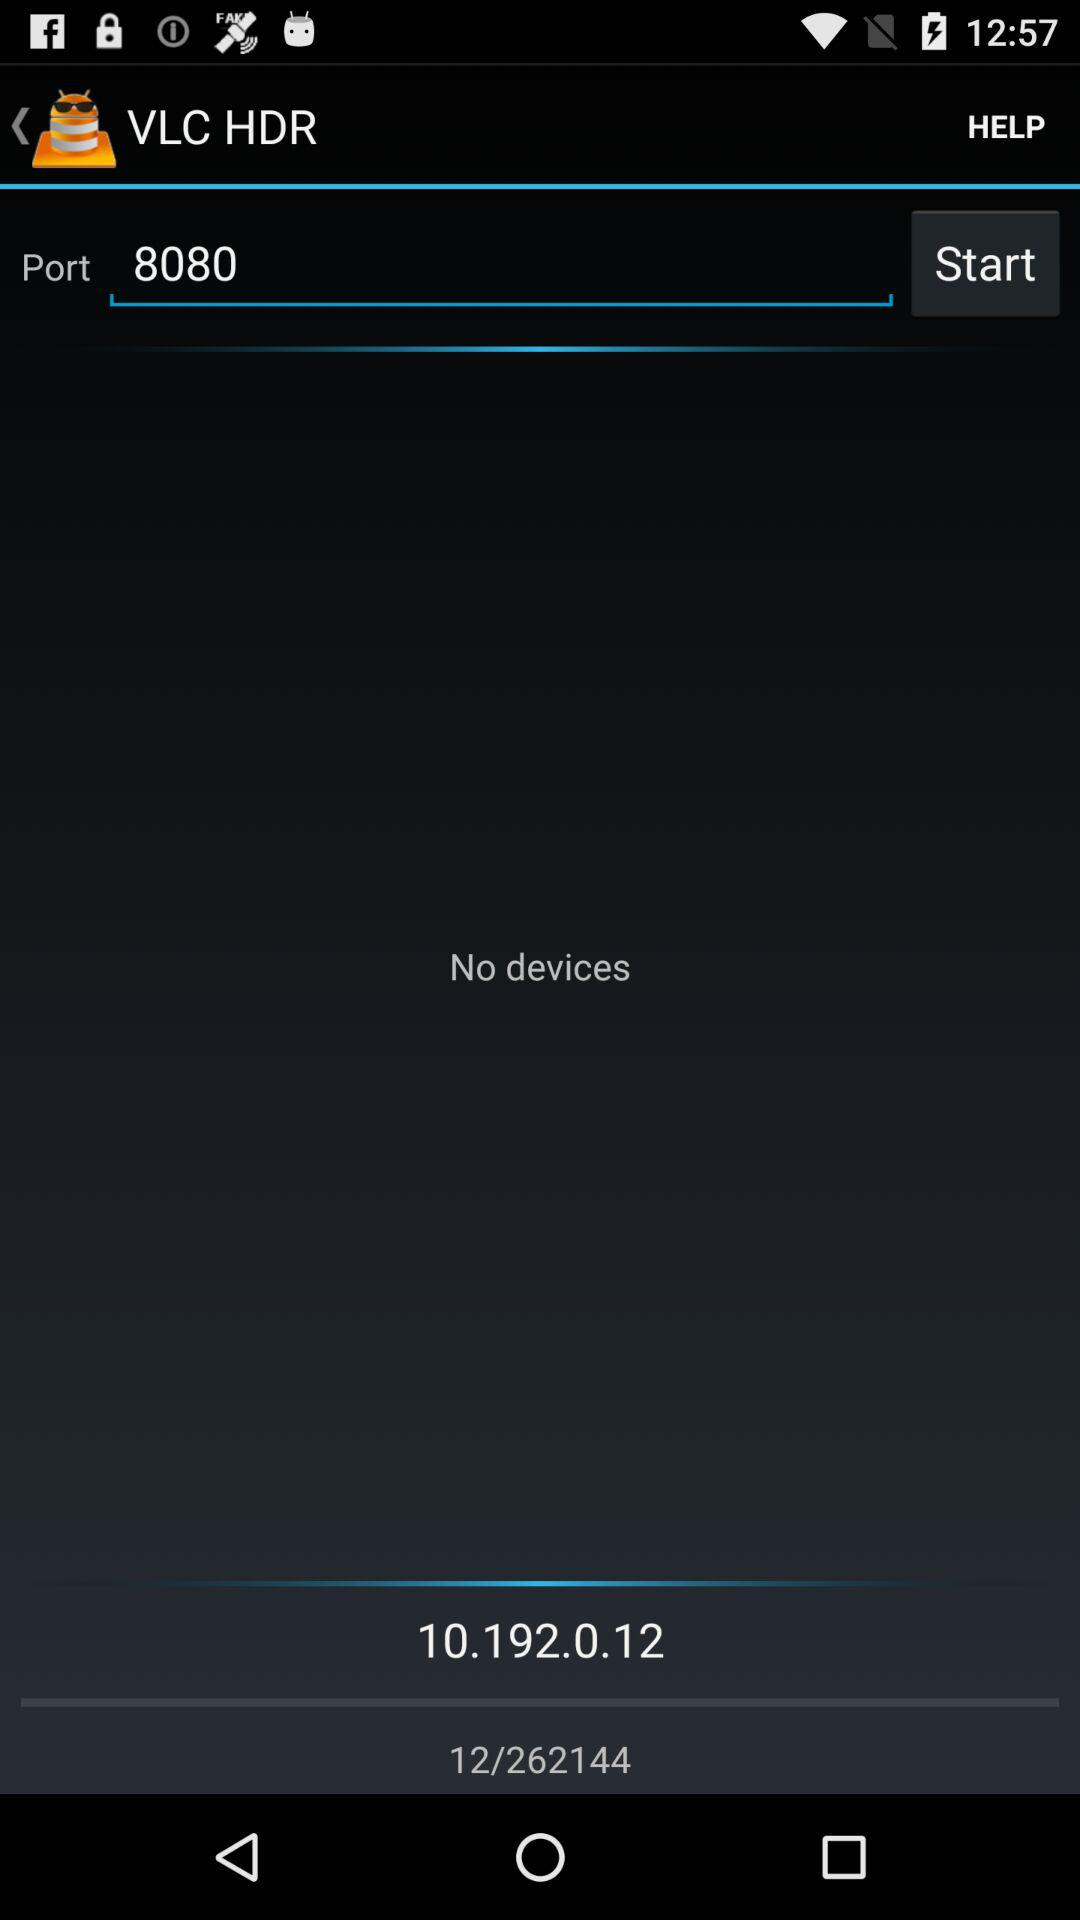What is the port number?
Answer the question using a single word or phrase. 8080 